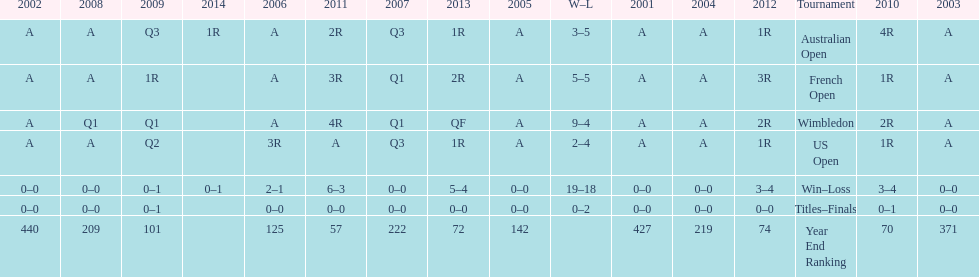Which years was a ranking below 200 achieved? 2005, 2006, 2009, 2010, 2011, 2012, 2013. 